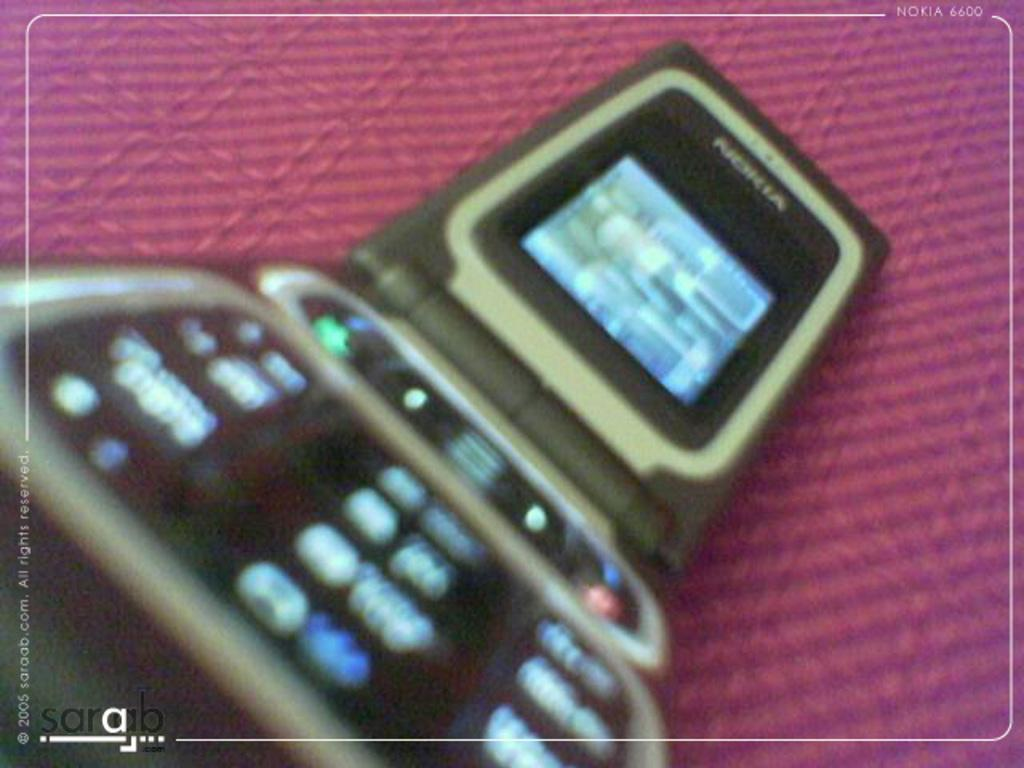What electronic device is visible in the image? There is a mobile phone in the image. What color is the surface on which the mobile phone is placed? The mobile phone is on a pink surface. Where can text be found in the image? There is text in the right top corner and the left bottom corner of the image. Is there a water fountain visible in the image? No, there is no water fountain present in the image. 